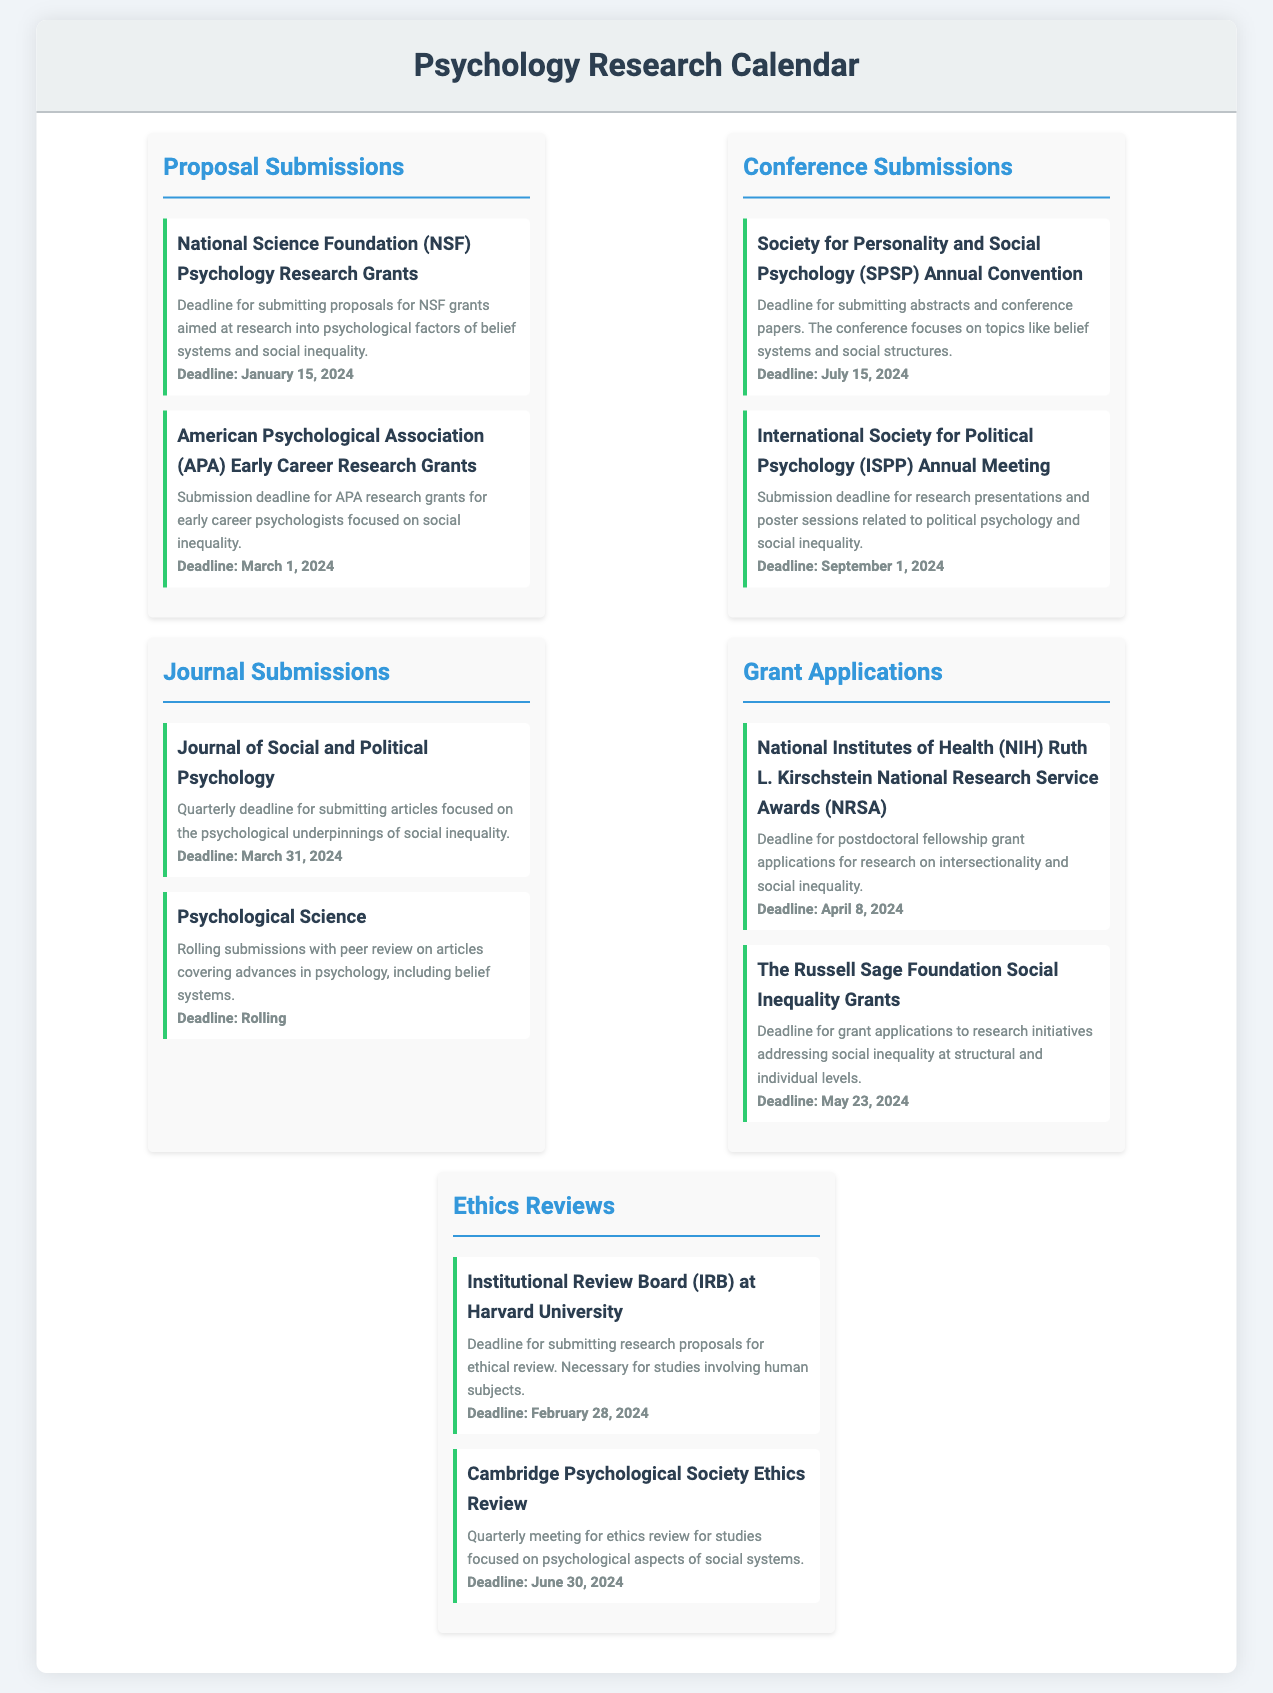What is the deadline for NSF Psychology Research Grants? The document specifies that the deadline for submitting proposals for NSF grants is January 15, 2024.
Answer: January 15, 2024 When is the conference submission deadline for the SPSP Annual Convention? According to the document, the deadline for submitting abstracts and conference papers for the SPSP Annual Convention is July 15, 2024.
Answer: July 15, 2024 What type of grants does the APA offer? The document states that the APA offers Early Career Research Grants focused on social inequality.
Answer: Early Career Research Grants What is the deadline for submitting articles to the Journal of Social and Political Psychology? The document indicates that the quarterly deadline for submitting articles is March 31, 2024.
Answer: March 31, 2024 How often are submissions accepted for Psychological Science? The document notes that Psychological Science has rolling submissions with peer review.
Answer: Rolling What is the last date for applications to the Russell Sage Foundation Social Inequality Grants? According to the document, the deadline for the Russell Sage Foundation grants is May 23, 2024.
Answer: May 23, 2024 Which institution reviews ethical proposals for research involving human subjects? The document mentions the Institutional Review Board (IRB) at Harvard University as the organization reviewing such proposals.
Answer: Harvard University What is the deadline for the Cambridge Psychological Society Ethics Review? The document specifies that the deadline for the Cambridge Psychological Society Ethics Review is June 30, 2024.
Answer: June 30, 2024 What significant topic does the SPSP Annual Convention focus on? The document states that the SPSP Annual Convention focuses on topics related to belief systems and social structures.
Answer: Belief systems and social structures 